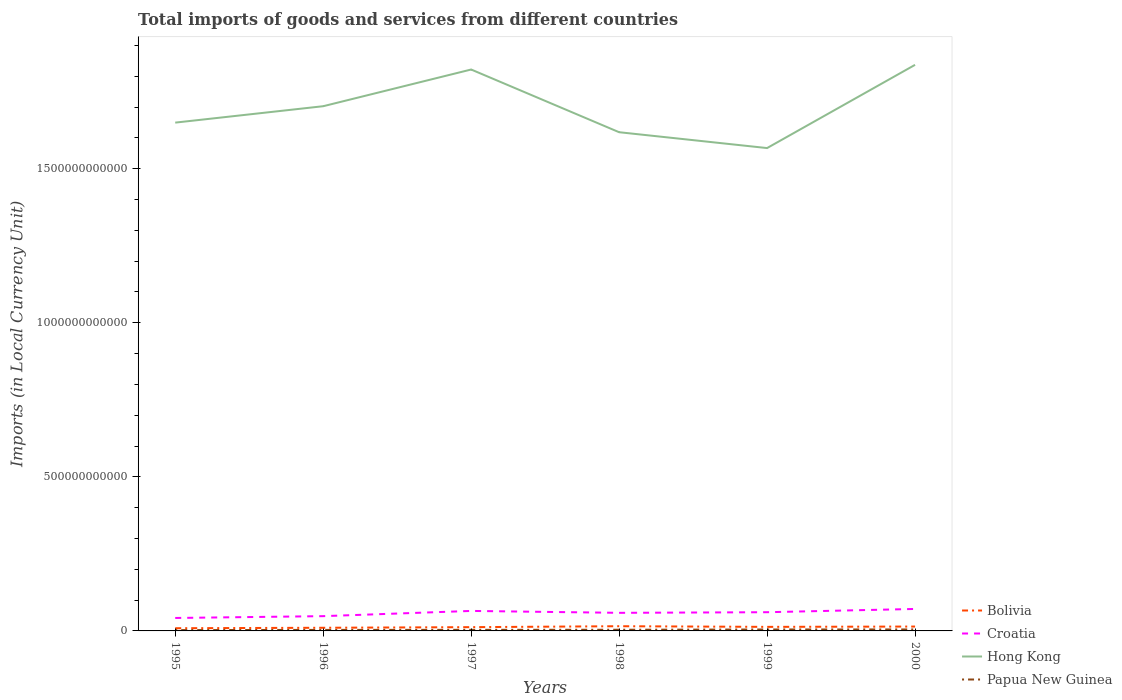How many different coloured lines are there?
Provide a succinct answer. 4. Across all years, what is the maximum Amount of goods and services imports in Bolivia?
Your answer should be compact. 8.76e+09. In which year was the Amount of goods and services imports in Bolivia maximum?
Your answer should be compact. 1995. What is the total Amount of goods and services imports in Croatia in the graph?
Your response must be concise. -1.28e+1. What is the difference between the highest and the second highest Amount of goods and services imports in Hong Kong?
Provide a short and direct response. 2.70e+11. Is the Amount of goods and services imports in Croatia strictly greater than the Amount of goods and services imports in Bolivia over the years?
Give a very brief answer. No. How many lines are there?
Give a very brief answer. 4. How many years are there in the graph?
Give a very brief answer. 6. What is the difference between two consecutive major ticks on the Y-axis?
Offer a very short reply. 5.00e+11. Does the graph contain grids?
Make the answer very short. No. Where does the legend appear in the graph?
Keep it short and to the point. Bottom right. How many legend labels are there?
Make the answer very short. 4. How are the legend labels stacked?
Make the answer very short. Vertical. What is the title of the graph?
Keep it short and to the point. Total imports of goods and services from different countries. What is the label or title of the X-axis?
Offer a terse response. Years. What is the label or title of the Y-axis?
Offer a terse response. Imports (in Local Currency Unit). What is the Imports (in Local Currency Unit) in Bolivia in 1995?
Offer a very short reply. 8.76e+09. What is the Imports (in Local Currency Unit) of Croatia in 1995?
Keep it short and to the point. 4.20e+1. What is the Imports (in Local Currency Unit) of Hong Kong in 1995?
Offer a very short reply. 1.65e+12. What is the Imports (in Local Currency Unit) in Papua New Guinea in 1995?
Keep it short and to the point. 2.71e+09. What is the Imports (in Local Currency Unit) in Bolivia in 1996?
Your response must be concise. 1.02e+1. What is the Imports (in Local Currency Unit) of Croatia in 1996?
Your answer should be compact. 4.79e+1. What is the Imports (in Local Currency Unit) in Hong Kong in 1996?
Offer a very short reply. 1.70e+12. What is the Imports (in Local Currency Unit) in Papua New Guinea in 1996?
Provide a short and direct response. 3.29e+09. What is the Imports (in Local Currency Unit) in Bolivia in 1997?
Make the answer very short. 1.22e+1. What is the Imports (in Local Currency Unit) in Croatia in 1997?
Your response must be concise. 6.49e+1. What is the Imports (in Local Currency Unit) of Hong Kong in 1997?
Ensure brevity in your answer.  1.82e+12. What is the Imports (in Local Currency Unit) in Papua New Guinea in 1997?
Your response must be concise. 3.54e+09. What is the Imports (in Local Currency Unit) in Bolivia in 1998?
Give a very brief answer. 1.53e+1. What is the Imports (in Local Currency Unit) in Croatia in 1998?
Provide a succinct answer. 5.87e+1. What is the Imports (in Local Currency Unit) in Hong Kong in 1998?
Offer a very short reply. 1.62e+12. What is the Imports (in Local Currency Unit) of Papua New Guinea in 1998?
Give a very brief answer. 3.81e+09. What is the Imports (in Local Currency Unit) in Bolivia in 1999?
Offer a terse response. 1.31e+1. What is the Imports (in Local Currency Unit) in Croatia in 1999?
Your response must be concise. 6.07e+1. What is the Imports (in Local Currency Unit) of Hong Kong in 1999?
Offer a terse response. 1.57e+12. What is the Imports (in Local Currency Unit) of Papua New Guinea in 1999?
Keep it short and to the point. 4.67e+09. What is the Imports (in Local Currency Unit) of Bolivia in 2000?
Make the answer very short. 1.42e+1. What is the Imports (in Local Currency Unit) in Croatia in 2000?
Your response must be concise. 7.13e+1. What is the Imports (in Local Currency Unit) of Hong Kong in 2000?
Keep it short and to the point. 1.84e+12. What is the Imports (in Local Currency Unit) of Papua New Guinea in 2000?
Your response must be concise. 4.79e+09. Across all years, what is the maximum Imports (in Local Currency Unit) of Bolivia?
Ensure brevity in your answer.  1.53e+1. Across all years, what is the maximum Imports (in Local Currency Unit) in Croatia?
Make the answer very short. 7.13e+1. Across all years, what is the maximum Imports (in Local Currency Unit) of Hong Kong?
Your response must be concise. 1.84e+12. Across all years, what is the maximum Imports (in Local Currency Unit) of Papua New Guinea?
Keep it short and to the point. 4.79e+09. Across all years, what is the minimum Imports (in Local Currency Unit) of Bolivia?
Make the answer very short. 8.76e+09. Across all years, what is the minimum Imports (in Local Currency Unit) in Croatia?
Provide a short and direct response. 4.20e+1. Across all years, what is the minimum Imports (in Local Currency Unit) in Hong Kong?
Your answer should be compact. 1.57e+12. Across all years, what is the minimum Imports (in Local Currency Unit) in Papua New Guinea?
Your response must be concise. 2.71e+09. What is the total Imports (in Local Currency Unit) in Bolivia in the graph?
Provide a succinct answer. 7.38e+1. What is the total Imports (in Local Currency Unit) of Croatia in the graph?
Keep it short and to the point. 3.46e+11. What is the total Imports (in Local Currency Unit) of Hong Kong in the graph?
Your answer should be very brief. 1.02e+13. What is the total Imports (in Local Currency Unit) in Papua New Guinea in the graph?
Offer a very short reply. 2.28e+1. What is the difference between the Imports (in Local Currency Unit) of Bolivia in 1995 and that in 1996?
Give a very brief answer. -1.47e+09. What is the difference between the Imports (in Local Currency Unit) in Croatia in 1995 and that in 1996?
Offer a very short reply. -5.91e+09. What is the difference between the Imports (in Local Currency Unit) in Hong Kong in 1995 and that in 1996?
Give a very brief answer. -5.33e+1. What is the difference between the Imports (in Local Currency Unit) in Papua New Guinea in 1995 and that in 1996?
Offer a terse response. -5.81e+08. What is the difference between the Imports (in Local Currency Unit) in Bolivia in 1995 and that in 1997?
Offer a very short reply. -3.46e+09. What is the difference between the Imports (in Local Currency Unit) of Croatia in 1995 and that in 1997?
Offer a very short reply. -2.29e+1. What is the difference between the Imports (in Local Currency Unit) in Hong Kong in 1995 and that in 1997?
Offer a terse response. -1.72e+11. What is the difference between the Imports (in Local Currency Unit) in Papua New Guinea in 1995 and that in 1997?
Make the answer very short. -8.36e+08. What is the difference between the Imports (in Local Currency Unit) of Bolivia in 1995 and that in 1998?
Make the answer very short. -6.49e+09. What is the difference between the Imports (in Local Currency Unit) in Croatia in 1995 and that in 1998?
Ensure brevity in your answer.  -1.67e+1. What is the difference between the Imports (in Local Currency Unit) in Hong Kong in 1995 and that in 1998?
Provide a succinct answer. 3.11e+1. What is the difference between the Imports (in Local Currency Unit) of Papua New Guinea in 1995 and that in 1998?
Make the answer very short. -1.10e+09. What is the difference between the Imports (in Local Currency Unit) of Bolivia in 1995 and that in 1999?
Ensure brevity in your answer.  -4.38e+09. What is the difference between the Imports (in Local Currency Unit) of Croatia in 1995 and that in 1999?
Give a very brief answer. -1.87e+1. What is the difference between the Imports (in Local Currency Unit) of Hong Kong in 1995 and that in 1999?
Your answer should be very brief. 8.26e+1. What is the difference between the Imports (in Local Currency Unit) of Papua New Guinea in 1995 and that in 1999?
Provide a short and direct response. -1.96e+09. What is the difference between the Imports (in Local Currency Unit) in Bolivia in 1995 and that in 2000?
Give a very brief answer. -5.42e+09. What is the difference between the Imports (in Local Currency Unit) in Croatia in 1995 and that in 2000?
Your answer should be very brief. -2.93e+1. What is the difference between the Imports (in Local Currency Unit) in Hong Kong in 1995 and that in 2000?
Provide a succinct answer. -1.88e+11. What is the difference between the Imports (in Local Currency Unit) of Papua New Guinea in 1995 and that in 2000?
Offer a very short reply. -2.09e+09. What is the difference between the Imports (in Local Currency Unit) of Bolivia in 1996 and that in 1997?
Your answer should be compact. -1.99e+09. What is the difference between the Imports (in Local Currency Unit) in Croatia in 1996 and that in 1997?
Your answer should be compact. -1.70e+1. What is the difference between the Imports (in Local Currency Unit) of Hong Kong in 1996 and that in 1997?
Give a very brief answer. -1.19e+11. What is the difference between the Imports (in Local Currency Unit) in Papua New Guinea in 1996 and that in 1997?
Offer a very short reply. -2.55e+08. What is the difference between the Imports (in Local Currency Unit) of Bolivia in 1996 and that in 1998?
Provide a succinct answer. -5.02e+09. What is the difference between the Imports (in Local Currency Unit) in Croatia in 1996 and that in 1998?
Provide a succinct answer. -1.08e+1. What is the difference between the Imports (in Local Currency Unit) of Hong Kong in 1996 and that in 1998?
Your answer should be very brief. 8.44e+1. What is the difference between the Imports (in Local Currency Unit) in Papua New Guinea in 1996 and that in 1998?
Your answer should be compact. -5.21e+08. What is the difference between the Imports (in Local Currency Unit) in Bolivia in 1996 and that in 1999?
Offer a very short reply. -2.90e+09. What is the difference between the Imports (in Local Currency Unit) of Croatia in 1996 and that in 1999?
Your answer should be very brief. -1.28e+1. What is the difference between the Imports (in Local Currency Unit) of Hong Kong in 1996 and that in 1999?
Ensure brevity in your answer.  1.36e+11. What is the difference between the Imports (in Local Currency Unit) of Papua New Guinea in 1996 and that in 1999?
Offer a terse response. -1.38e+09. What is the difference between the Imports (in Local Currency Unit) of Bolivia in 1996 and that in 2000?
Offer a terse response. -3.95e+09. What is the difference between the Imports (in Local Currency Unit) in Croatia in 1996 and that in 2000?
Your response must be concise. -2.33e+1. What is the difference between the Imports (in Local Currency Unit) of Hong Kong in 1996 and that in 2000?
Make the answer very short. -1.34e+11. What is the difference between the Imports (in Local Currency Unit) in Papua New Guinea in 1996 and that in 2000?
Keep it short and to the point. -1.51e+09. What is the difference between the Imports (in Local Currency Unit) of Bolivia in 1997 and that in 1998?
Make the answer very short. -3.03e+09. What is the difference between the Imports (in Local Currency Unit) in Croatia in 1997 and that in 1998?
Your answer should be compact. 6.20e+09. What is the difference between the Imports (in Local Currency Unit) in Hong Kong in 1997 and that in 1998?
Make the answer very short. 2.03e+11. What is the difference between the Imports (in Local Currency Unit) of Papua New Guinea in 1997 and that in 1998?
Your response must be concise. -2.66e+08. What is the difference between the Imports (in Local Currency Unit) of Bolivia in 1997 and that in 1999?
Give a very brief answer. -9.14e+08. What is the difference between the Imports (in Local Currency Unit) of Croatia in 1997 and that in 1999?
Your response must be concise. 4.18e+09. What is the difference between the Imports (in Local Currency Unit) of Hong Kong in 1997 and that in 1999?
Keep it short and to the point. 2.55e+11. What is the difference between the Imports (in Local Currency Unit) of Papua New Guinea in 1997 and that in 1999?
Give a very brief answer. -1.13e+09. What is the difference between the Imports (in Local Currency Unit) in Bolivia in 1997 and that in 2000?
Your answer should be compact. -1.96e+09. What is the difference between the Imports (in Local Currency Unit) in Croatia in 1997 and that in 2000?
Your answer should be compact. -6.38e+09. What is the difference between the Imports (in Local Currency Unit) of Hong Kong in 1997 and that in 2000?
Make the answer very short. -1.52e+1. What is the difference between the Imports (in Local Currency Unit) in Papua New Guinea in 1997 and that in 2000?
Provide a short and direct response. -1.25e+09. What is the difference between the Imports (in Local Currency Unit) in Bolivia in 1998 and that in 1999?
Give a very brief answer. 2.12e+09. What is the difference between the Imports (in Local Currency Unit) of Croatia in 1998 and that in 1999?
Keep it short and to the point. -2.02e+09. What is the difference between the Imports (in Local Currency Unit) of Hong Kong in 1998 and that in 1999?
Your answer should be very brief. 5.15e+1. What is the difference between the Imports (in Local Currency Unit) in Papua New Guinea in 1998 and that in 1999?
Provide a short and direct response. -8.59e+08. What is the difference between the Imports (in Local Currency Unit) of Bolivia in 1998 and that in 2000?
Make the answer very short. 1.07e+09. What is the difference between the Imports (in Local Currency Unit) in Croatia in 1998 and that in 2000?
Keep it short and to the point. -1.26e+1. What is the difference between the Imports (in Local Currency Unit) of Hong Kong in 1998 and that in 2000?
Your answer should be very brief. -2.19e+11. What is the difference between the Imports (in Local Currency Unit) of Papua New Guinea in 1998 and that in 2000?
Provide a succinct answer. -9.85e+08. What is the difference between the Imports (in Local Currency Unit) of Bolivia in 1999 and that in 2000?
Your answer should be very brief. -1.05e+09. What is the difference between the Imports (in Local Currency Unit) in Croatia in 1999 and that in 2000?
Keep it short and to the point. -1.06e+1. What is the difference between the Imports (in Local Currency Unit) in Hong Kong in 1999 and that in 2000?
Give a very brief answer. -2.70e+11. What is the difference between the Imports (in Local Currency Unit) in Papua New Guinea in 1999 and that in 2000?
Your answer should be compact. -1.25e+08. What is the difference between the Imports (in Local Currency Unit) in Bolivia in 1995 and the Imports (in Local Currency Unit) in Croatia in 1996?
Your answer should be compact. -3.92e+1. What is the difference between the Imports (in Local Currency Unit) of Bolivia in 1995 and the Imports (in Local Currency Unit) of Hong Kong in 1996?
Offer a very short reply. -1.69e+12. What is the difference between the Imports (in Local Currency Unit) in Bolivia in 1995 and the Imports (in Local Currency Unit) in Papua New Guinea in 1996?
Keep it short and to the point. 5.48e+09. What is the difference between the Imports (in Local Currency Unit) of Croatia in 1995 and the Imports (in Local Currency Unit) of Hong Kong in 1996?
Provide a short and direct response. -1.66e+12. What is the difference between the Imports (in Local Currency Unit) of Croatia in 1995 and the Imports (in Local Currency Unit) of Papua New Guinea in 1996?
Your response must be concise. 3.87e+1. What is the difference between the Imports (in Local Currency Unit) in Hong Kong in 1995 and the Imports (in Local Currency Unit) in Papua New Guinea in 1996?
Offer a very short reply. 1.65e+12. What is the difference between the Imports (in Local Currency Unit) in Bolivia in 1995 and the Imports (in Local Currency Unit) in Croatia in 1997?
Provide a succinct answer. -5.61e+1. What is the difference between the Imports (in Local Currency Unit) in Bolivia in 1995 and the Imports (in Local Currency Unit) in Hong Kong in 1997?
Provide a short and direct response. -1.81e+12. What is the difference between the Imports (in Local Currency Unit) of Bolivia in 1995 and the Imports (in Local Currency Unit) of Papua New Guinea in 1997?
Ensure brevity in your answer.  5.22e+09. What is the difference between the Imports (in Local Currency Unit) in Croatia in 1995 and the Imports (in Local Currency Unit) in Hong Kong in 1997?
Your answer should be very brief. -1.78e+12. What is the difference between the Imports (in Local Currency Unit) in Croatia in 1995 and the Imports (in Local Currency Unit) in Papua New Guinea in 1997?
Offer a very short reply. 3.85e+1. What is the difference between the Imports (in Local Currency Unit) in Hong Kong in 1995 and the Imports (in Local Currency Unit) in Papua New Guinea in 1997?
Your answer should be very brief. 1.65e+12. What is the difference between the Imports (in Local Currency Unit) of Bolivia in 1995 and the Imports (in Local Currency Unit) of Croatia in 1998?
Provide a succinct answer. -4.99e+1. What is the difference between the Imports (in Local Currency Unit) of Bolivia in 1995 and the Imports (in Local Currency Unit) of Hong Kong in 1998?
Your response must be concise. -1.61e+12. What is the difference between the Imports (in Local Currency Unit) of Bolivia in 1995 and the Imports (in Local Currency Unit) of Papua New Guinea in 1998?
Ensure brevity in your answer.  4.95e+09. What is the difference between the Imports (in Local Currency Unit) in Croatia in 1995 and the Imports (in Local Currency Unit) in Hong Kong in 1998?
Your answer should be compact. -1.58e+12. What is the difference between the Imports (in Local Currency Unit) in Croatia in 1995 and the Imports (in Local Currency Unit) in Papua New Guinea in 1998?
Ensure brevity in your answer.  3.82e+1. What is the difference between the Imports (in Local Currency Unit) in Hong Kong in 1995 and the Imports (in Local Currency Unit) in Papua New Guinea in 1998?
Your response must be concise. 1.65e+12. What is the difference between the Imports (in Local Currency Unit) of Bolivia in 1995 and the Imports (in Local Currency Unit) of Croatia in 1999?
Make the answer very short. -5.20e+1. What is the difference between the Imports (in Local Currency Unit) of Bolivia in 1995 and the Imports (in Local Currency Unit) of Hong Kong in 1999?
Offer a very short reply. -1.56e+12. What is the difference between the Imports (in Local Currency Unit) of Bolivia in 1995 and the Imports (in Local Currency Unit) of Papua New Guinea in 1999?
Offer a very short reply. 4.09e+09. What is the difference between the Imports (in Local Currency Unit) of Croatia in 1995 and the Imports (in Local Currency Unit) of Hong Kong in 1999?
Your response must be concise. -1.52e+12. What is the difference between the Imports (in Local Currency Unit) in Croatia in 1995 and the Imports (in Local Currency Unit) in Papua New Guinea in 1999?
Ensure brevity in your answer.  3.74e+1. What is the difference between the Imports (in Local Currency Unit) in Hong Kong in 1995 and the Imports (in Local Currency Unit) in Papua New Guinea in 1999?
Offer a very short reply. 1.64e+12. What is the difference between the Imports (in Local Currency Unit) of Bolivia in 1995 and the Imports (in Local Currency Unit) of Croatia in 2000?
Provide a short and direct response. -6.25e+1. What is the difference between the Imports (in Local Currency Unit) in Bolivia in 1995 and the Imports (in Local Currency Unit) in Hong Kong in 2000?
Your answer should be very brief. -1.83e+12. What is the difference between the Imports (in Local Currency Unit) in Bolivia in 1995 and the Imports (in Local Currency Unit) in Papua New Guinea in 2000?
Your answer should be very brief. 3.97e+09. What is the difference between the Imports (in Local Currency Unit) of Croatia in 1995 and the Imports (in Local Currency Unit) of Hong Kong in 2000?
Keep it short and to the point. -1.80e+12. What is the difference between the Imports (in Local Currency Unit) of Croatia in 1995 and the Imports (in Local Currency Unit) of Papua New Guinea in 2000?
Offer a terse response. 3.72e+1. What is the difference between the Imports (in Local Currency Unit) in Hong Kong in 1995 and the Imports (in Local Currency Unit) in Papua New Guinea in 2000?
Keep it short and to the point. 1.64e+12. What is the difference between the Imports (in Local Currency Unit) of Bolivia in 1996 and the Imports (in Local Currency Unit) of Croatia in 1997?
Offer a terse response. -5.47e+1. What is the difference between the Imports (in Local Currency Unit) in Bolivia in 1996 and the Imports (in Local Currency Unit) in Hong Kong in 1997?
Make the answer very short. -1.81e+12. What is the difference between the Imports (in Local Currency Unit) in Bolivia in 1996 and the Imports (in Local Currency Unit) in Papua New Guinea in 1997?
Ensure brevity in your answer.  6.69e+09. What is the difference between the Imports (in Local Currency Unit) of Croatia in 1996 and the Imports (in Local Currency Unit) of Hong Kong in 1997?
Give a very brief answer. -1.77e+12. What is the difference between the Imports (in Local Currency Unit) of Croatia in 1996 and the Imports (in Local Currency Unit) of Papua New Guinea in 1997?
Ensure brevity in your answer.  4.44e+1. What is the difference between the Imports (in Local Currency Unit) of Hong Kong in 1996 and the Imports (in Local Currency Unit) of Papua New Guinea in 1997?
Offer a very short reply. 1.70e+12. What is the difference between the Imports (in Local Currency Unit) of Bolivia in 1996 and the Imports (in Local Currency Unit) of Croatia in 1998?
Ensure brevity in your answer.  -4.85e+1. What is the difference between the Imports (in Local Currency Unit) of Bolivia in 1996 and the Imports (in Local Currency Unit) of Hong Kong in 1998?
Give a very brief answer. -1.61e+12. What is the difference between the Imports (in Local Currency Unit) of Bolivia in 1996 and the Imports (in Local Currency Unit) of Papua New Guinea in 1998?
Keep it short and to the point. 6.43e+09. What is the difference between the Imports (in Local Currency Unit) in Croatia in 1996 and the Imports (in Local Currency Unit) in Hong Kong in 1998?
Keep it short and to the point. -1.57e+12. What is the difference between the Imports (in Local Currency Unit) in Croatia in 1996 and the Imports (in Local Currency Unit) in Papua New Guinea in 1998?
Give a very brief answer. 4.41e+1. What is the difference between the Imports (in Local Currency Unit) in Hong Kong in 1996 and the Imports (in Local Currency Unit) in Papua New Guinea in 1998?
Give a very brief answer. 1.70e+12. What is the difference between the Imports (in Local Currency Unit) in Bolivia in 1996 and the Imports (in Local Currency Unit) in Croatia in 1999?
Your answer should be very brief. -5.05e+1. What is the difference between the Imports (in Local Currency Unit) in Bolivia in 1996 and the Imports (in Local Currency Unit) in Hong Kong in 1999?
Your answer should be compact. -1.56e+12. What is the difference between the Imports (in Local Currency Unit) of Bolivia in 1996 and the Imports (in Local Currency Unit) of Papua New Guinea in 1999?
Make the answer very short. 5.57e+09. What is the difference between the Imports (in Local Currency Unit) of Croatia in 1996 and the Imports (in Local Currency Unit) of Hong Kong in 1999?
Provide a short and direct response. -1.52e+12. What is the difference between the Imports (in Local Currency Unit) of Croatia in 1996 and the Imports (in Local Currency Unit) of Papua New Guinea in 1999?
Ensure brevity in your answer.  4.33e+1. What is the difference between the Imports (in Local Currency Unit) in Hong Kong in 1996 and the Imports (in Local Currency Unit) in Papua New Guinea in 1999?
Ensure brevity in your answer.  1.70e+12. What is the difference between the Imports (in Local Currency Unit) of Bolivia in 1996 and the Imports (in Local Currency Unit) of Croatia in 2000?
Provide a short and direct response. -6.11e+1. What is the difference between the Imports (in Local Currency Unit) of Bolivia in 1996 and the Imports (in Local Currency Unit) of Hong Kong in 2000?
Your answer should be compact. -1.83e+12. What is the difference between the Imports (in Local Currency Unit) in Bolivia in 1996 and the Imports (in Local Currency Unit) in Papua New Guinea in 2000?
Your answer should be compact. 5.44e+09. What is the difference between the Imports (in Local Currency Unit) in Croatia in 1996 and the Imports (in Local Currency Unit) in Hong Kong in 2000?
Ensure brevity in your answer.  -1.79e+12. What is the difference between the Imports (in Local Currency Unit) in Croatia in 1996 and the Imports (in Local Currency Unit) in Papua New Guinea in 2000?
Give a very brief answer. 4.31e+1. What is the difference between the Imports (in Local Currency Unit) in Hong Kong in 1996 and the Imports (in Local Currency Unit) in Papua New Guinea in 2000?
Provide a short and direct response. 1.70e+12. What is the difference between the Imports (in Local Currency Unit) in Bolivia in 1997 and the Imports (in Local Currency Unit) in Croatia in 1998?
Ensure brevity in your answer.  -4.65e+1. What is the difference between the Imports (in Local Currency Unit) of Bolivia in 1997 and the Imports (in Local Currency Unit) of Hong Kong in 1998?
Provide a succinct answer. -1.61e+12. What is the difference between the Imports (in Local Currency Unit) of Bolivia in 1997 and the Imports (in Local Currency Unit) of Papua New Guinea in 1998?
Provide a succinct answer. 8.42e+09. What is the difference between the Imports (in Local Currency Unit) in Croatia in 1997 and the Imports (in Local Currency Unit) in Hong Kong in 1998?
Provide a short and direct response. -1.55e+12. What is the difference between the Imports (in Local Currency Unit) of Croatia in 1997 and the Imports (in Local Currency Unit) of Papua New Guinea in 1998?
Offer a terse response. 6.11e+1. What is the difference between the Imports (in Local Currency Unit) in Hong Kong in 1997 and the Imports (in Local Currency Unit) in Papua New Guinea in 1998?
Your answer should be very brief. 1.82e+12. What is the difference between the Imports (in Local Currency Unit) of Bolivia in 1997 and the Imports (in Local Currency Unit) of Croatia in 1999?
Provide a succinct answer. -4.85e+1. What is the difference between the Imports (in Local Currency Unit) in Bolivia in 1997 and the Imports (in Local Currency Unit) in Hong Kong in 1999?
Your answer should be very brief. -1.55e+12. What is the difference between the Imports (in Local Currency Unit) in Bolivia in 1997 and the Imports (in Local Currency Unit) in Papua New Guinea in 1999?
Ensure brevity in your answer.  7.56e+09. What is the difference between the Imports (in Local Currency Unit) of Croatia in 1997 and the Imports (in Local Currency Unit) of Hong Kong in 1999?
Your answer should be very brief. -1.50e+12. What is the difference between the Imports (in Local Currency Unit) in Croatia in 1997 and the Imports (in Local Currency Unit) in Papua New Guinea in 1999?
Provide a short and direct response. 6.02e+1. What is the difference between the Imports (in Local Currency Unit) in Hong Kong in 1997 and the Imports (in Local Currency Unit) in Papua New Guinea in 1999?
Your response must be concise. 1.82e+12. What is the difference between the Imports (in Local Currency Unit) in Bolivia in 1997 and the Imports (in Local Currency Unit) in Croatia in 2000?
Your answer should be compact. -5.91e+1. What is the difference between the Imports (in Local Currency Unit) of Bolivia in 1997 and the Imports (in Local Currency Unit) of Hong Kong in 2000?
Your answer should be compact. -1.82e+12. What is the difference between the Imports (in Local Currency Unit) in Bolivia in 1997 and the Imports (in Local Currency Unit) in Papua New Guinea in 2000?
Offer a terse response. 7.43e+09. What is the difference between the Imports (in Local Currency Unit) of Croatia in 1997 and the Imports (in Local Currency Unit) of Hong Kong in 2000?
Provide a succinct answer. -1.77e+12. What is the difference between the Imports (in Local Currency Unit) in Croatia in 1997 and the Imports (in Local Currency Unit) in Papua New Guinea in 2000?
Your response must be concise. 6.01e+1. What is the difference between the Imports (in Local Currency Unit) of Hong Kong in 1997 and the Imports (in Local Currency Unit) of Papua New Guinea in 2000?
Give a very brief answer. 1.82e+12. What is the difference between the Imports (in Local Currency Unit) of Bolivia in 1998 and the Imports (in Local Currency Unit) of Croatia in 1999?
Keep it short and to the point. -4.55e+1. What is the difference between the Imports (in Local Currency Unit) in Bolivia in 1998 and the Imports (in Local Currency Unit) in Hong Kong in 1999?
Offer a terse response. -1.55e+12. What is the difference between the Imports (in Local Currency Unit) of Bolivia in 1998 and the Imports (in Local Currency Unit) of Papua New Guinea in 1999?
Make the answer very short. 1.06e+1. What is the difference between the Imports (in Local Currency Unit) in Croatia in 1998 and the Imports (in Local Currency Unit) in Hong Kong in 1999?
Keep it short and to the point. -1.51e+12. What is the difference between the Imports (in Local Currency Unit) in Croatia in 1998 and the Imports (in Local Currency Unit) in Papua New Guinea in 1999?
Make the answer very short. 5.40e+1. What is the difference between the Imports (in Local Currency Unit) of Hong Kong in 1998 and the Imports (in Local Currency Unit) of Papua New Guinea in 1999?
Give a very brief answer. 1.61e+12. What is the difference between the Imports (in Local Currency Unit) in Bolivia in 1998 and the Imports (in Local Currency Unit) in Croatia in 2000?
Offer a very short reply. -5.60e+1. What is the difference between the Imports (in Local Currency Unit) of Bolivia in 1998 and the Imports (in Local Currency Unit) of Hong Kong in 2000?
Your response must be concise. -1.82e+12. What is the difference between the Imports (in Local Currency Unit) of Bolivia in 1998 and the Imports (in Local Currency Unit) of Papua New Guinea in 2000?
Provide a succinct answer. 1.05e+1. What is the difference between the Imports (in Local Currency Unit) in Croatia in 1998 and the Imports (in Local Currency Unit) in Hong Kong in 2000?
Your answer should be compact. -1.78e+12. What is the difference between the Imports (in Local Currency Unit) in Croatia in 1998 and the Imports (in Local Currency Unit) in Papua New Guinea in 2000?
Give a very brief answer. 5.39e+1. What is the difference between the Imports (in Local Currency Unit) in Hong Kong in 1998 and the Imports (in Local Currency Unit) in Papua New Guinea in 2000?
Provide a succinct answer. 1.61e+12. What is the difference between the Imports (in Local Currency Unit) of Bolivia in 1999 and the Imports (in Local Currency Unit) of Croatia in 2000?
Your answer should be very brief. -5.81e+1. What is the difference between the Imports (in Local Currency Unit) of Bolivia in 1999 and the Imports (in Local Currency Unit) of Hong Kong in 2000?
Give a very brief answer. -1.82e+12. What is the difference between the Imports (in Local Currency Unit) of Bolivia in 1999 and the Imports (in Local Currency Unit) of Papua New Guinea in 2000?
Your response must be concise. 8.35e+09. What is the difference between the Imports (in Local Currency Unit) of Croatia in 1999 and the Imports (in Local Currency Unit) of Hong Kong in 2000?
Offer a terse response. -1.78e+12. What is the difference between the Imports (in Local Currency Unit) in Croatia in 1999 and the Imports (in Local Currency Unit) in Papua New Guinea in 2000?
Your answer should be compact. 5.59e+1. What is the difference between the Imports (in Local Currency Unit) of Hong Kong in 1999 and the Imports (in Local Currency Unit) of Papua New Guinea in 2000?
Offer a terse response. 1.56e+12. What is the average Imports (in Local Currency Unit) of Bolivia per year?
Your response must be concise. 1.23e+1. What is the average Imports (in Local Currency Unit) in Croatia per year?
Make the answer very short. 5.76e+1. What is the average Imports (in Local Currency Unit) of Hong Kong per year?
Make the answer very short. 1.70e+12. What is the average Imports (in Local Currency Unit) of Papua New Guinea per year?
Your response must be concise. 3.80e+09. In the year 1995, what is the difference between the Imports (in Local Currency Unit) of Bolivia and Imports (in Local Currency Unit) of Croatia?
Your response must be concise. -3.33e+1. In the year 1995, what is the difference between the Imports (in Local Currency Unit) in Bolivia and Imports (in Local Currency Unit) in Hong Kong?
Make the answer very short. -1.64e+12. In the year 1995, what is the difference between the Imports (in Local Currency Unit) in Bolivia and Imports (in Local Currency Unit) in Papua New Guinea?
Offer a very short reply. 6.06e+09. In the year 1995, what is the difference between the Imports (in Local Currency Unit) in Croatia and Imports (in Local Currency Unit) in Hong Kong?
Provide a short and direct response. -1.61e+12. In the year 1995, what is the difference between the Imports (in Local Currency Unit) of Croatia and Imports (in Local Currency Unit) of Papua New Guinea?
Your answer should be compact. 3.93e+1. In the year 1995, what is the difference between the Imports (in Local Currency Unit) in Hong Kong and Imports (in Local Currency Unit) in Papua New Guinea?
Make the answer very short. 1.65e+12. In the year 1996, what is the difference between the Imports (in Local Currency Unit) of Bolivia and Imports (in Local Currency Unit) of Croatia?
Your answer should be compact. -3.77e+1. In the year 1996, what is the difference between the Imports (in Local Currency Unit) of Bolivia and Imports (in Local Currency Unit) of Hong Kong?
Keep it short and to the point. -1.69e+12. In the year 1996, what is the difference between the Imports (in Local Currency Unit) in Bolivia and Imports (in Local Currency Unit) in Papua New Guinea?
Your answer should be compact. 6.95e+09. In the year 1996, what is the difference between the Imports (in Local Currency Unit) of Croatia and Imports (in Local Currency Unit) of Hong Kong?
Give a very brief answer. -1.65e+12. In the year 1996, what is the difference between the Imports (in Local Currency Unit) in Croatia and Imports (in Local Currency Unit) in Papua New Guinea?
Your response must be concise. 4.47e+1. In the year 1996, what is the difference between the Imports (in Local Currency Unit) of Hong Kong and Imports (in Local Currency Unit) of Papua New Guinea?
Offer a very short reply. 1.70e+12. In the year 1997, what is the difference between the Imports (in Local Currency Unit) of Bolivia and Imports (in Local Currency Unit) of Croatia?
Provide a short and direct response. -5.27e+1. In the year 1997, what is the difference between the Imports (in Local Currency Unit) in Bolivia and Imports (in Local Currency Unit) in Hong Kong?
Ensure brevity in your answer.  -1.81e+12. In the year 1997, what is the difference between the Imports (in Local Currency Unit) of Bolivia and Imports (in Local Currency Unit) of Papua New Guinea?
Give a very brief answer. 8.68e+09. In the year 1997, what is the difference between the Imports (in Local Currency Unit) in Croatia and Imports (in Local Currency Unit) in Hong Kong?
Provide a succinct answer. -1.76e+12. In the year 1997, what is the difference between the Imports (in Local Currency Unit) of Croatia and Imports (in Local Currency Unit) of Papua New Guinea?
Offer a very short reply. 6.14e+1. In the year 1997, what is the difference between the Imports (in Local Currency Unit) in Hong Kong and Imports (in Local Currency Unit) in Papua New Guinea?
Keep it short and to the point. 1.82e+12. In the year 1998, what is the difference between the Imports (in Local Currency Unit) in Bolivia and Imports (in Local Currency Unit) in Croatia?
Your response must be concise. -4.35e+1. In the year 1998, what is the difference between the Imports (in Local Currency Unit) in Bolivia and Imports (in Local Currency Unit) in Hong Kong?
Keep it short and to the point. -1.60e+12. In the year 1998, what is the difference between the Imports (in Local Currency Unit) in Bolivia and Imports (in Local Currency Unit) in Papua New Guinea?
Your response must be concise. 1.14e+1. In the year 1998, what is the difference between the Imports (in Local Currency Unit) in Croatia and Imports (in Local Currency Unit) in Hong Kong?
Keep it short and to the point. -1.56e+12. In the year 1998, what is the difference between the Imports (in Local Currency Unit) in Croatia and Imports (in Local Currency Unit) in Papua New Guinea?
Make the answer very short. 5.49e+1. In the year 1998, what is the difference between the Imports (in Local Currency Unit) in Hong Kong and Imports (in Local Currency Unit) in Papua New Guinea?
Keep it short and to the point. 1.61e+12. In the year 1999, what is the difference between the Imports (in Local Currency Unit) of Bolivia and Imports (in Local Currency Unit) of Croatia?
Your response must be concise. -4.76e+1. In the year 1999, what is the difference between the Imports (in Local Currency Unit) of Bolivia and Imports (in Local Currency Unit) of Hong Kong?
Provide a short and direct response. -1.55e+12. In the year 1999, what is the difference between the Imports (in Local Currency Unit) of Bolivia and Imports (in Local Currency Unit) of Papua New Guinea?
Ensure brevity in your answer.  8.47e+09. In the year 1999, what is the difference between the Imports (in Local Currency Unit) in Croatia and Imports (in Local Currency Unit) in Hong Kong?
Your answer should be very brief. -1.51e+12. In the year 1999, what is the difference between the Imports (in Local Currency Unit) of Croatia and Imports (in Local Currency Unit) of Papua New Guinea?
Keep it short and to the point. 5.61e+1. In the year 1999, what is the difference between the Imports (in Local Currency Unit) in Hong Kong and Imports (in Local Currency Unit) in Papua New Guinea?
Provide a short and direct response. 1.56e+12. In the year 2000, what is the difference between the Imports (in Local Currency Unit) of Bolivia and Imports (in Local Currency Unit) of Croatia?
Offer a very short reply. -5.71e+1. In the year 2000, what is the difference between the Imports (in Local Currency Unit) in Bolivia and Imports (in Local Currency Unit) in Hong Kong?
Provide a succinct answer. -1.82e+12. In the year 2000, what is the difference between the Imports (in Local Currency Unit) of Bolivia and Imports (in Local Currency Unit) of Papua New Guinea?
Give a very brief answer. 9.39e+09. In the year 2000, what is the difference between the Imports (in Local Currency Unit) in Croatia and Imports (in Local Currency Unit) in Hong Kong?
Give a very brief answer. -1.77e+12. In the year 2000, what is the difference between the Imports (in Local Currency Unit) of Croatia and Imports (in Local Currency Unit) of Papua New Guinea?
Your answer should be very brief. 6.65e+1. In the year 2000, what is the difference between the Imports (in Local Currency Unit) of Hong Kong and Imports (in Local Currency Unit) of Papua New Guinea?
Keep it short and to the point. 1.83e+12. What is the ratio of the Imports (in Local Currency Unit) in Bolivia in 1995 to that in 1996?
Provide a short and direct response. 0.86. What is the ratio of the Imports (in Local Currency Unit) in Croatia in 1995 to that in 1996?
Give a very brief answer. 0.88. What is the ratio of the Imports (in Local Currency Unit) in Hong Kong in 1995 to that in 1996?
Provide a succinct answer. 0.97. What is the ratio of the Imports (in Local Currency Unit) of Papua New Guinea in 1995 to that in 1996?
Provide a short and direct response. 0.82. What is the ratio of the Imports (in Local Currency Unit) in Bolivia in 1995 to that in 1997?
Offer a very short reply. 0.72. What is the ratio of the Imports (in Local Currency Unit) in Croatia in 1995 to that in 1997?
Ensure brevity in your answer.  0.65. What is the ratio of the Imports (in Local Currency Unit) in Hong Kong in 1995 to that in 1997?
Your answer should be compact. 0.91. What is the ratio of the Imports (in Local Currency Unit) in Papua New Guinea in 1995 to that in 1997?
Offer a very short reply. 0.76. What is the ratio of the Imports (in Local Currency Unit) of Bolivia in 1995 to that in 1998?
Make the answer very short. 0.57. What is the ratio of the Imports (in Local Currency Unit) in Croatia in 1995 to that in 1998?
Your answer should be very brief. 0.72. What is the ratio of the Imports (in Local Currency Unit) in Hong Kong in 1995 to that in 1998?
Give a very brief answer. 1.02. What is the ratio of the Imports (in Local Currency Unit) in Papua New Guinea in 1995 to that in 1998?
Provide a succinct answer. 0.71. What is the ratio of the Imports (in Local Currency Unit) in Bolivia in 1995 to that in 1999?
Keep it short and to the point. 0.67. What is the ratio of the Imports (in Local Currency Unit) of Croatia in 1995 to that in 1999?
Your answer should be very brief. 0.69. What is the ratio of the Imports (in Local Currency Unit) of Hong Kong in 1995 to that in 1999?
Offer a very short reply. 1.05. What is the ratio of the Imports (in Local Currency Unit) in Papua New Guinea in 1995 to that in 1999?
Offer a very short reply. 0.58. What is the ratio of the Imports (in Local Currency Unit) in Bolivia in 1995 to that in 2000?
Your response must be concise. 0.62. What is the ratio of the Imports (in Local Currency Unit) of Croatia in 1995 to that in 2000?
Make the answer very short. 0.59. What is the ratio of the Imports (in Local Currency Unit) in Hong Kong in 1995 to that in 2000?
Offer a terse response. 0.9. What is the ratio of the Imports (in Local Currency Unit) of Papua New Guinea in 1995 to that in 2000?
Provide a short and direct response. 0.56. What is the ratio of the Imports (in Local Currency Unit) in Bolivia in 1996 to that in 1997?
Your answer should be very brief. 0.84. What is the ratio of the Imports (in Local Currency Unit) of Croatia in 1996 to that in 1997?
Ensure brevity in your answer.  0.74. What is the ratio of the Imports (in Local Currency Unit) of Hong Kong in 1996 to that in 1997?
Provide a succinct answer. 0.93. What is the ratio of the Imports (in Local Currency Unit) in Papua New Guinea in 1996 to that in 1997?
Ensure brevity in your answer.  0.93. What is the ratio of the Imports (in Local Currency Unit) in Bolivia in 1996 to that in 1998?
Keep it short and to the point. 0.67. What is the ratio of the Imports (in Local Currency Unit) of Croatia in 1996 to that in 1998?
Offer a terse response. 0.82. What is the ratio of the Imports (in Local Currency Unit) of Hong Kong in 1996 to that in 1998?
Provide a short and direct response. 1.05. What is the ratio of the Imports (in Local Currency Unit) in Papua New Guinea in 1996 to that in 1998?
Make the answer very short. 0.86. What is the ratio of the Imports (in Local Currency Unit) of Bolivia in 1996 to that in 1999?
Provide a succinct answer. 0.78. What is the ratio of the Imports (in Local Currency Unit) of Croatia in 1996 to that in 1999?
Your answer should be compact. 0.79. What is the ratio of the Imports (in Local Currency Unit) in Hong Kong in 1996 to that in 1999?
Provide a succinct answer. 1.09. What is the ratio of the Imports (in Local Currency Unit) of Papua New Guinea in 1996 to that in 1999?
Ensure brevity in your answer.  0.7. What is the ratio of the Imports (in Local Currency Unit) of Bolivia in 1996 to that in 2000?
Offer a very short reply. 0.72. What is the ratio of the Imports (in Local Currency Unit) of Croatia in 1996 to that in 2000?
Provide a short and direct response. 0.67. What is the ratio of the Imports (in Local Currency Unit) in Hong Kong in 1996 to that in 2000?
Make the answer very short. 0.93. What is the ratio of the Imports (in Local Currency Unit) of Papua New Guinea in 1996 to that in 2000?
Give a very brief answer. 0.69. What is the ratio of the Imports (in Local Currency Unit) of Bolivia in 1997 to that in 1998?
Offer a terse response. 0.8. What is the ratio of the Imports (in Local Currency Unit) of Croatia in 1997 to that in 1998?
Give a very brief answer. 1.11. What is the ratio of the Imports (in Local Currency Unit) of Hong Kong in 1997 to that in 1998?
Keep it short and to the point. 1.13. What is the ratio of the Imports (in Local Currency Unit) of Papua New Guinea in 1997 to that in 1998?
Ensure brevity in your answer.  0.93. What is the ratio of the Imports (in Local Currency Unit) of Bolivia in 1997 to that in 1999?
Your response must be concise. 0.93. What is the ratio of the Imports (in Local Currency Unit) of Croatia in 1997 to that in 1999?
Ensure brevity in your answer.  1.07. What is the ratio of the Imports (in Local Currency Unit) of Hong Kong in 1997 to that in 1999?
Ensure brevity in your answer.  1.16. What is the ratio of the Imports (in Local Currency Unit) in Papua New Guinea in 1997 to that in 1999?
Keep it short and to the point. 0.76. What is the ratio of the Imports (in Local Currency Unit) in Bolivia in 1997 to that in 2000?
Provide a succinct answer. 0.86. What is the ratio of the Imports (in Local Currency Unit) of Croatia in 1997 to that in 2000?
Provide a succinct answer. 0.91. What is the ratio of the Imports (in Local Currency Unit) in Hong Kong in 1997 to that in 2000?
Keep it short and to the point. 0.99. What is the ratio of the Imports (in Local Currency Unit) in Papua New Guinea in 1997 to that in 2000?
Make the answer very short. 0.74. What is the ratio of the Imports (in Local Currency Unit) of Bolivia in 1998 to that in 1999?
Your answer should be compact. 1.16. What is the ratio of the Imports (in Local Currency Unit) in Croatia in 1998 to that in 1999?
Provide a succinct answer. 0.97. What is the ratio of the Imports (in Local Currency Unit) in Hong Kong in 1998 to that in 1999?
Ensure brevity in your answer.  1.03. What is the ratio of the Imports (in Local Currency Unit) of Papua New Guinea in 1998 to that in 1999?
Offer a very short reply. 0.82. What is the ratio of the Imports (in Local Currency Unit) in Bolivia in 1998 to that in 2000?
Provide a succinct answer. 1.08. What is the ratio of the Imports (in Local Currency Unit) of Croatia in 1998 to that in 2000?
Ensure brevity in your answer.  0.82. What is the ratio of the Imports (in Local Currency Unit) in Hong Kong in 1998 to that in 2000?
Your answer should be very brief. 0.88. What is the ratio of the Imports (in Local Currency Unit) in Papua New Guinea in 1998 to that in 2000?
Ensure brevity in your answer.  0.79. What is the ratio of the Imports (in Local Currency Unit) of Bolivia in 1999 to that in 2000?
Your answer should be very brief. 0.93. What is the ratio of the Imports (in Local Currency Unit) in Croatia in 1999 to that in 2000?
Provide a succinct answer. 0.85. What is the ratio of the Imports (in Local Currency Unit) of Hong Kong in 1999 to that in 2000?
Provide a short and direct response. 0.85. What is the ratio of the Imports (in Local Currency Unit) in Papua New Guinea in 1999 to that in 2000?
Your answer should be very brief. 0.97. What is the difference between the highest and the second highest Imports (in Local Currency Unit) of Bolivia?
Your response must be concise. 1.07e+09. What is the difference between the highest and the second highest Imports (in Local Currency Unit) of Croatia?
Make the answer very short. 6.38e+09. What is the difference between the highest and the second highest Imports (in Local Currency Unit) of Hong Kong?
Your answer should be compact. 1.52e+1. What is the difference between the highest and the second highest Imports (in Local Currency Unit) in Papua New Guinea?
Make the answer very short. 1.25e+08. What is the difference between the highest and the lowest Imports (in Local Currency Unit) of Bolivia?
Your response must be concise. 6.49e+09. What is the difference between the highest and the lowest Imports (in Local Currency Unit) in Croatia?
Offer a very short reply. 2.93e+1. What is the difference between the highest and the lowest Imports (in Local Currency Unit) of Hong Kong?
Provide a short and direct response. 2.70e+11. What is the difference between the highest and the lowest Imports (in Local Currency Unit) of Papua New Guinea?
Keep it short and to the point. 2.09e+09. 